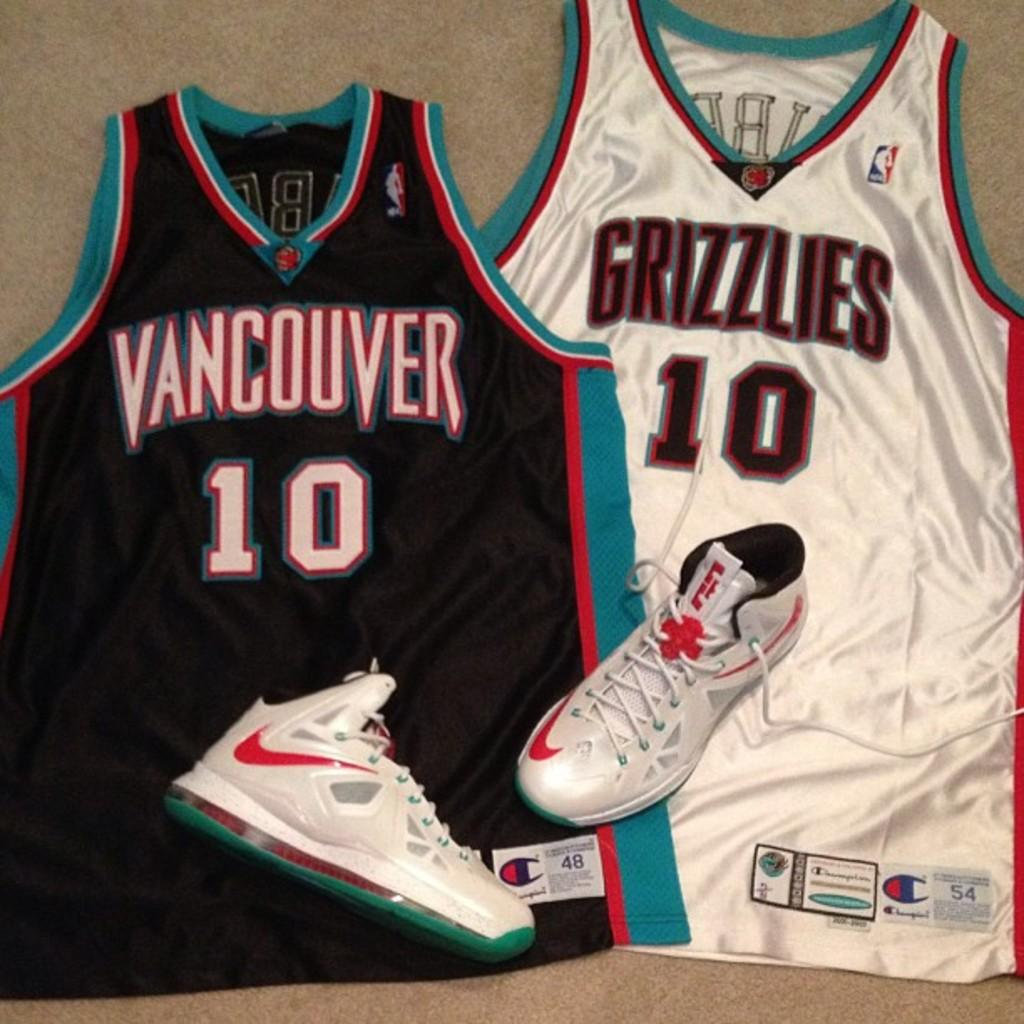<image>
Relay a brief, clear account of the picture shown. A Vancouver and Grizzlies jersey sits on the floor with a pair of nike shoes on them. 